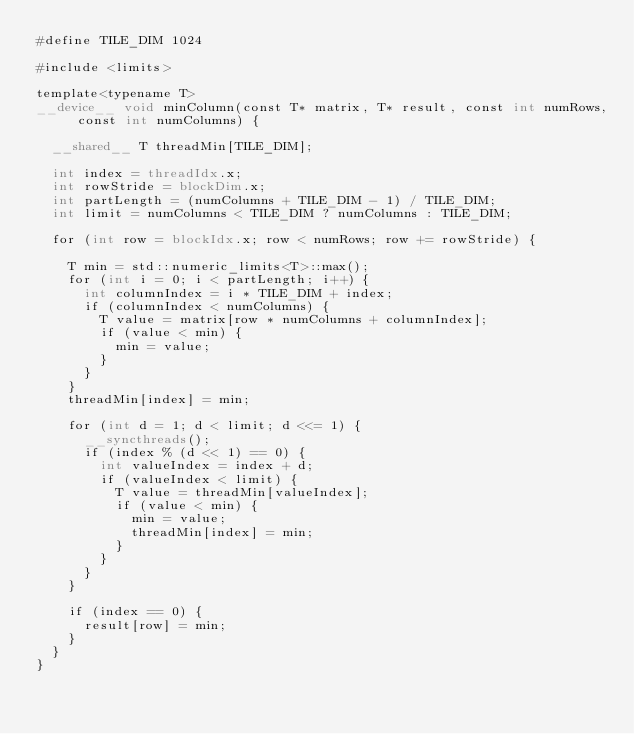<code> <loc_0><loc_0><loc_500><loc_500><_Cuda_>#define TILE_DIM 1024

#include <limits>

template<typename T>
__device__ void minColumn(const T* matrix, T* result, const int numRows, const int numColumns) {

  __shared__ T threadMin[TILE_DIM];

  int index = threadIdx.x;
  int rowStride = blockDim.x;
  int partLength = (numColumns + TILE_DIM - 1) / TILE_DIM;
  int limit = numColumns < TILE_DIM ? numColumns : TILE_DIM;

  for (int row = blockIdx.x; row < numRows; row += rowStride) {

    T min = std::numeric_limits<T>::max();
    for (int i = 0; i < partLength; i++) {
      int columnIndex = i * TILE_DIM + index;
      if (columnIndex < numColumns) {
        T value = matrix[row * numColumns + columnIndex];
        if (value < min) {
          min = value;
        }
      }
    }
    threadMin[index] = min;

    for (int d = 1; d < limit; d <<= 1) {
      __syncthreads();
      if (index % (d << 1) == 0) {
        int valueIndex = index + d;
        if (valueIndex < limit) {
          T value = threadMin[valueIndex];
          if (value < min) {
            min = value;
            threadMin[index] = min;
          }
        }
      }
    }

    if (index == 0) {
      result[row] = min;
    }
  }
}</code> 